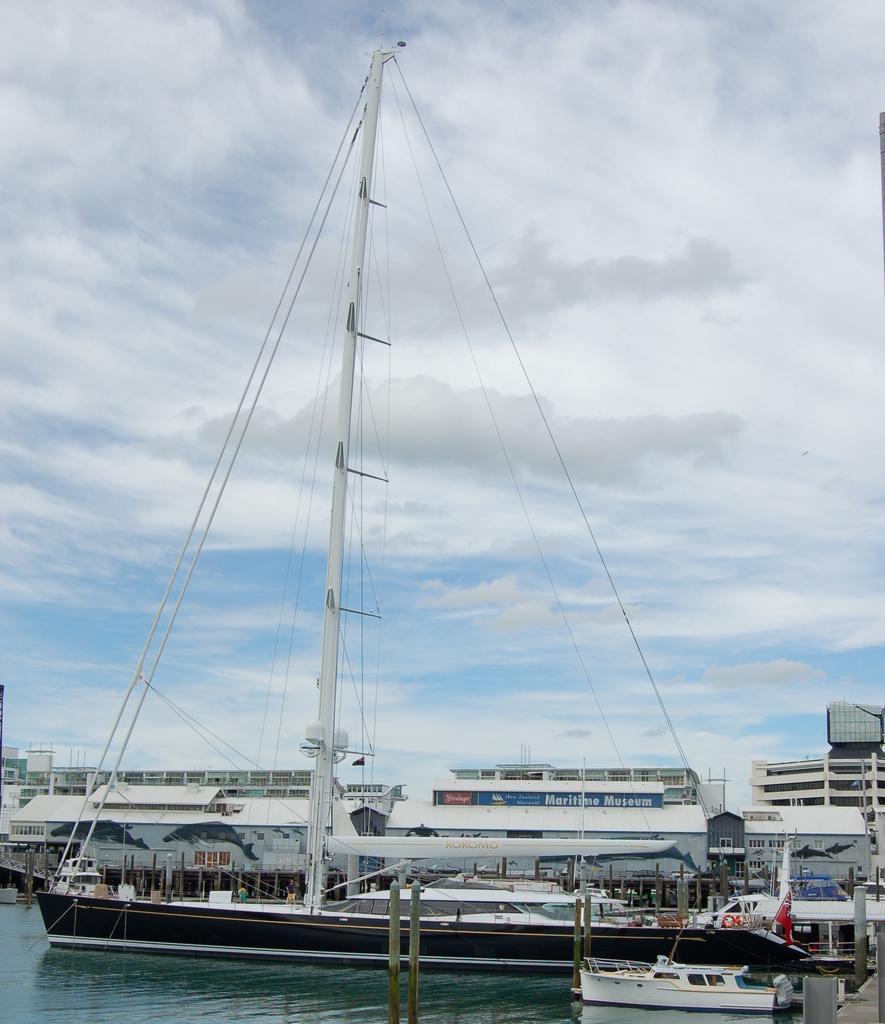Could you give a brief overview of what you see in this image? In the background we can see the clouds in the sky. In this picture we can see buildings, ship, poles, boat, flag, water and few objects. 